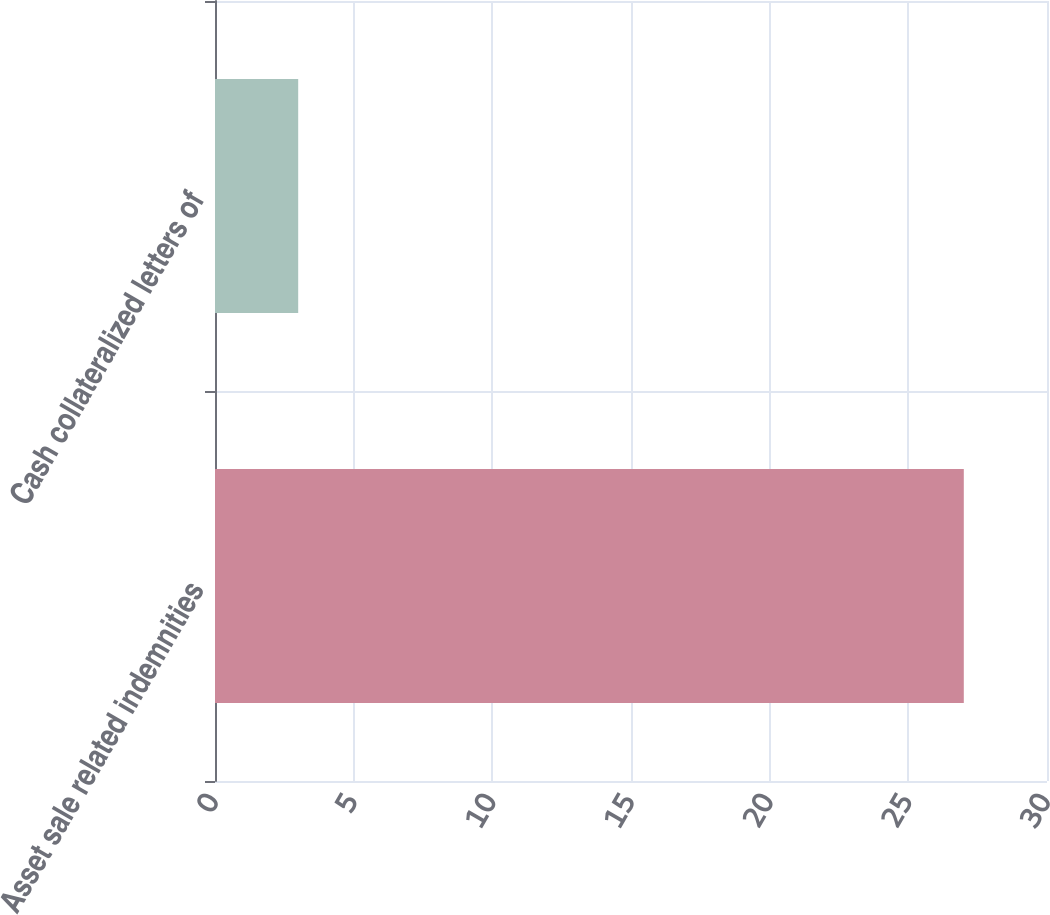<chart> <loc_0><loc_0><loc_500><loc_500><bar_chart><fcel>Asset sale related indemnities<fcel>Cash collateralized letters of<nl><fcel>27<fcel>3<nl></chart> 